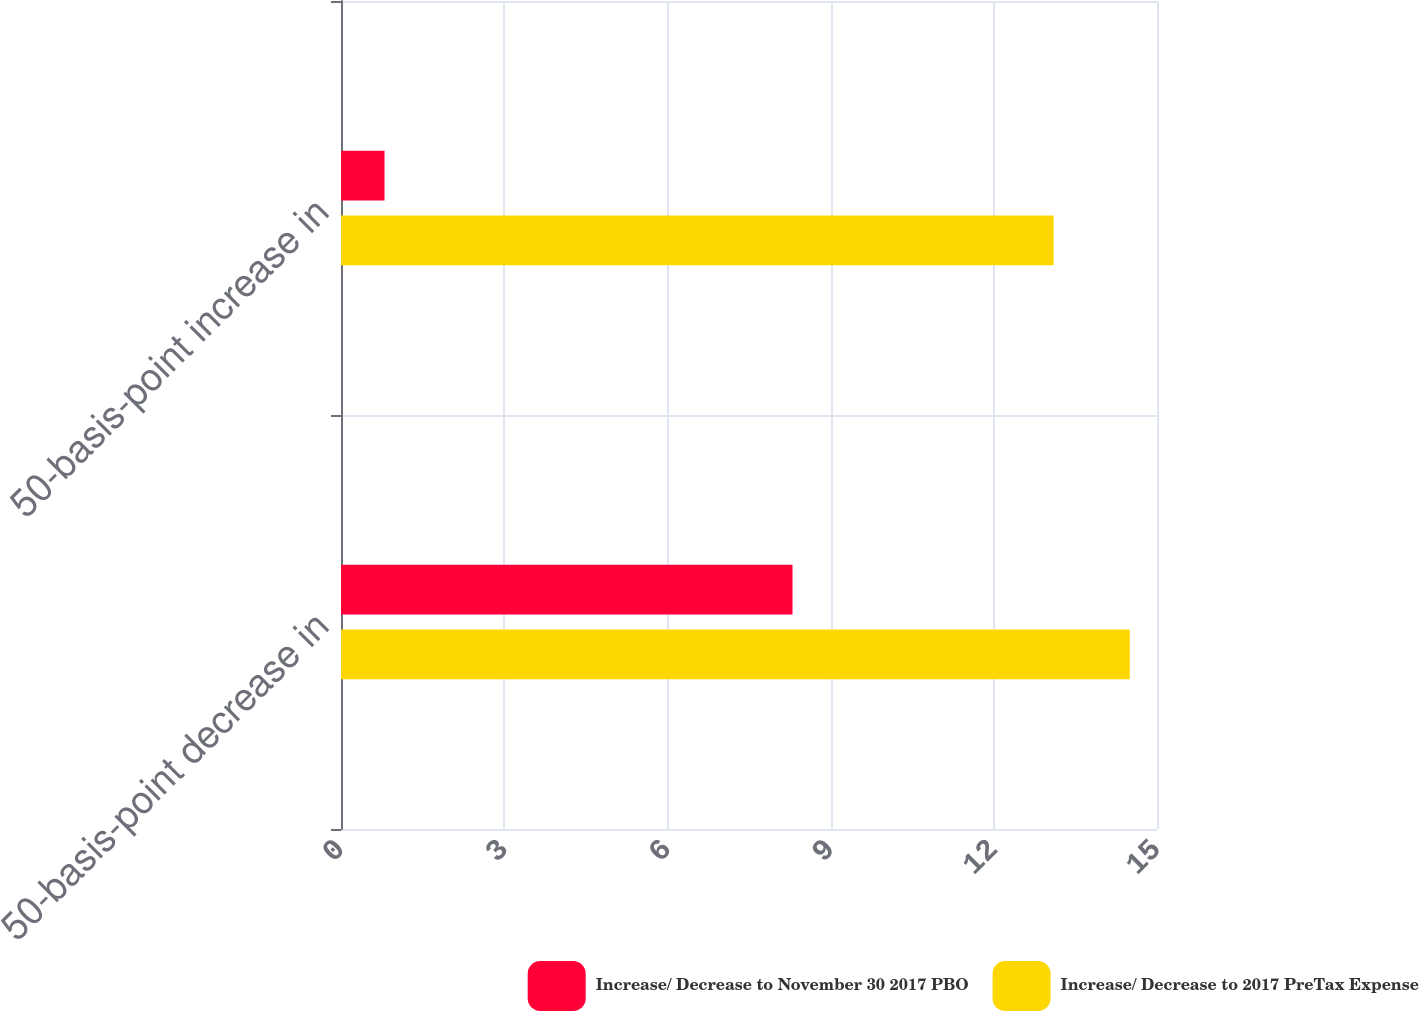Convert chart. <chart><loc_0><loc_0><loc_500><loc_500><stacked_bar_chart><ecel><fcel>50-basis-point decrease in<fcel>50-basis-point increase in<nl><fcel>Increase/ Decrease to November 30 2017 PBO<fcel>8.3<fcel>0.8<nl><fcel>Increase/ Decrease to 2017 PreTax Expense<fcel>14.5<fcel>13.1<nl></chart> 